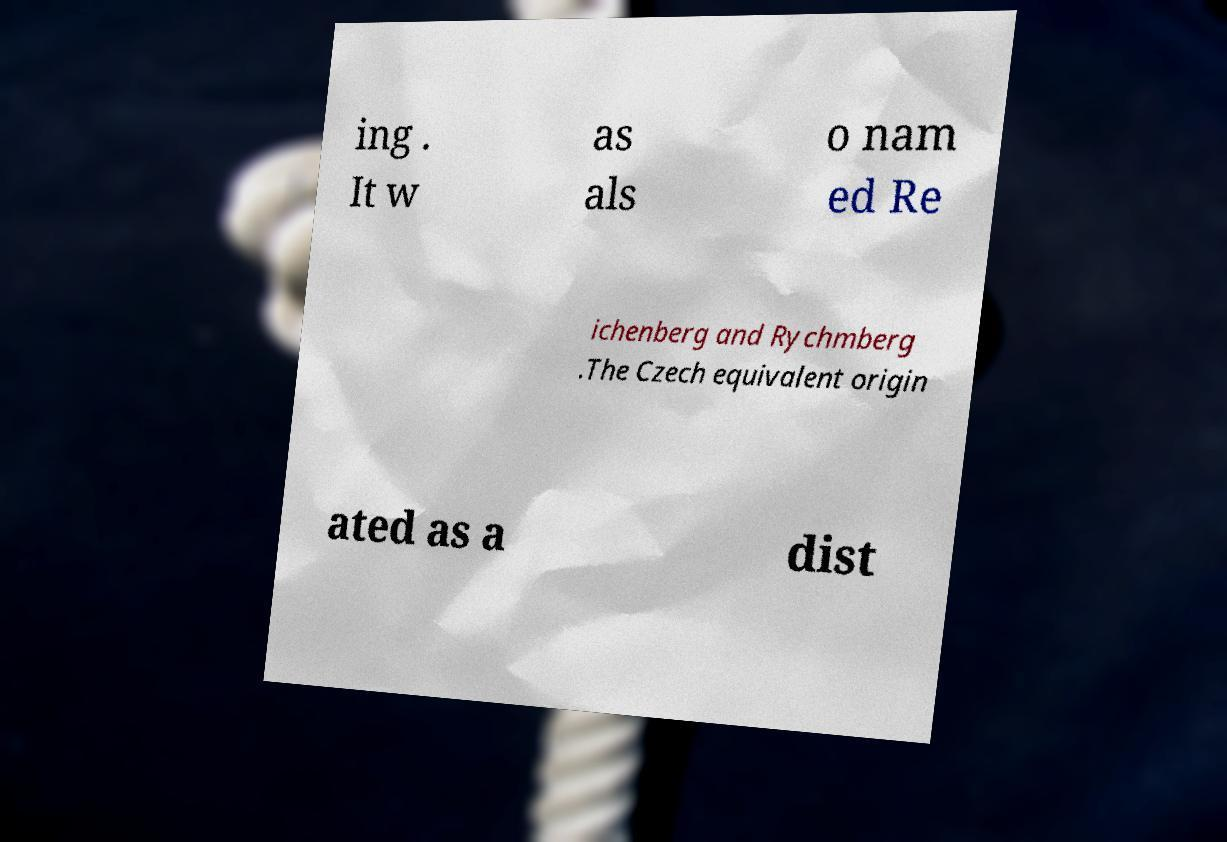Please identify and transcribe the text found in this image. ing . It w as als o nam ed Re ichenberg and Rychmberg .The Czech equivalent origin ated as a dist 